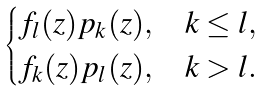<formula> <loc_0><loc_0><loc_500><loc_500>\begin{cases} f _ { l } ( z ) p _ { k } ( z ) , & k \leq l , \\ f _ { k } ( z ) p _ { l } ( z ) , & k > l . \end{cases}</formula> 